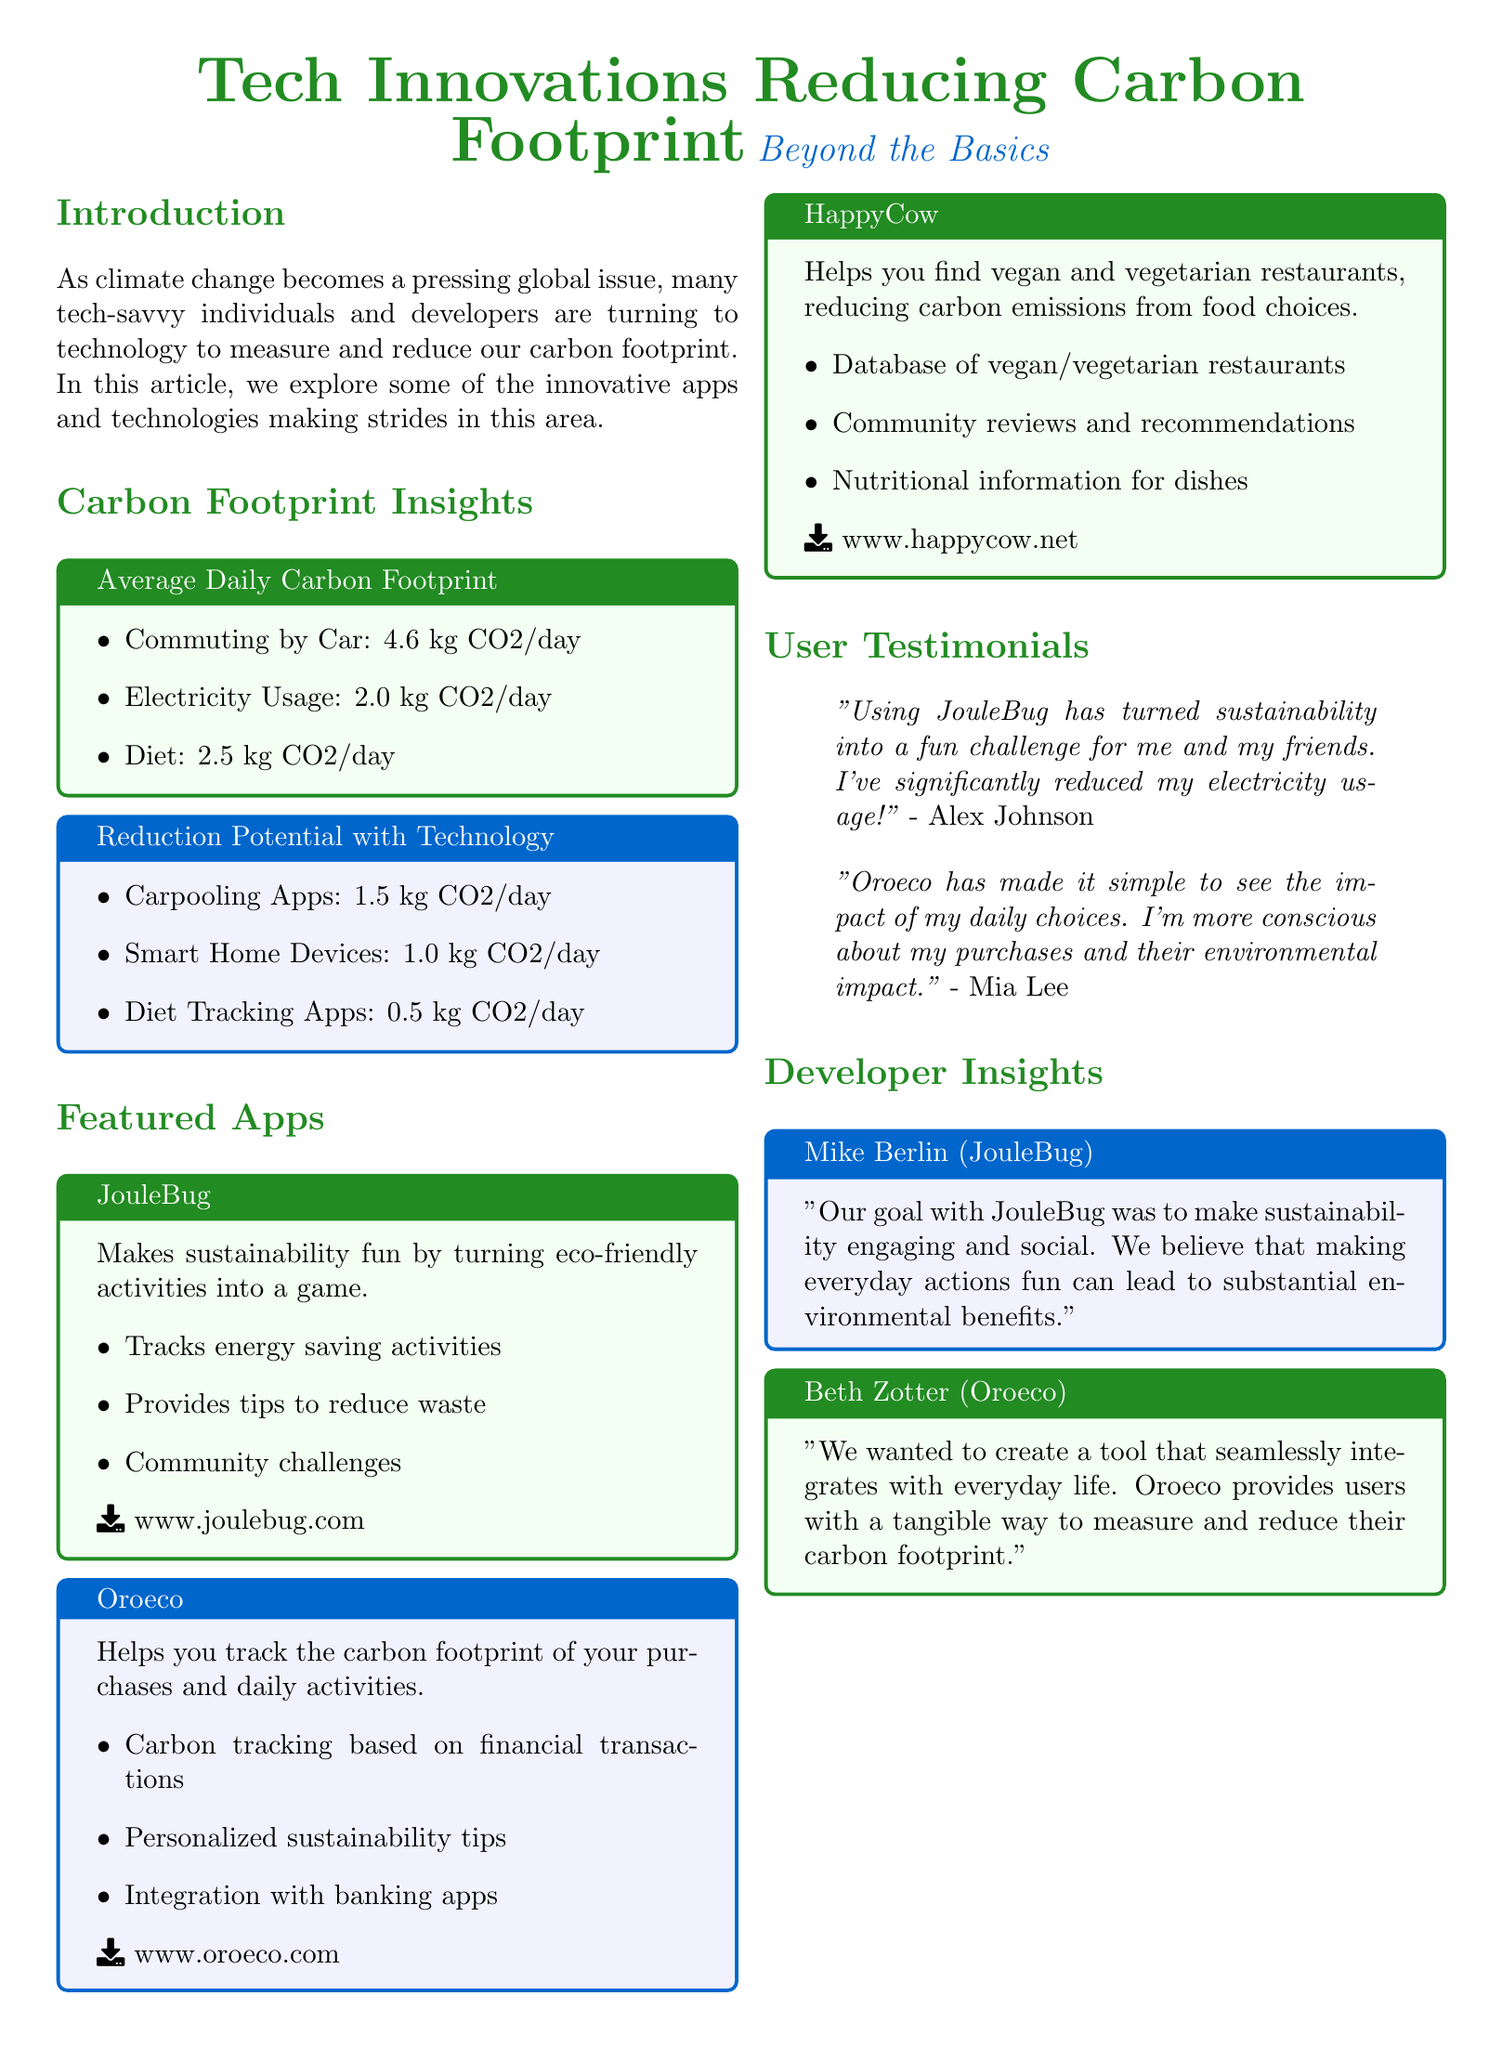What is the title of the magazine article? The title is presented prominently at the beginning of the document in a large font.
Answer: Tech Innovations Reducing Carbon Footprint What percentage of carbon emissions can be reduced by carpooling apps? The document lists potential reductions for various technologies, including carpooling apps.
Answer: 1.5 kg CO2/day What type of app is JouleBug categorized as? The document describes JouleBug's features and the way it engages users in sustainability practices.
Answer: Game Which app helps track the carbon footprint of purchases? The features of Oroeco indicate its functionality regarding financial transactions and carbon tracking.
Answer: Oroeco Who is quoted in the user testimonials? The document includes personal reflections from users about their experiences with the featured apps.
Answer: Alex Johnson and Mia Lee What is the carbon footprint of commuting by car? The document provides insights into daily carbon footprint averages from different activities.
Answer: 4.6 kg CO2/day Which device type can reduce 1.0 kg CO2 per day? The reduction potential section mentions various technologies and their impacts on carbon emissions.
Answer: Smart Home Devices What was the goal of Mike Berlin with JouleBug? The developer insights section shares the motivations behind the app's creation and its focus on user engagement.
Answer: Engagement and social connection What type of restaurants does HappyCow focus on? The document details the features of HappyCow and its specific target within the food industry.
Answer: Vegan and vegetarian restaurants 